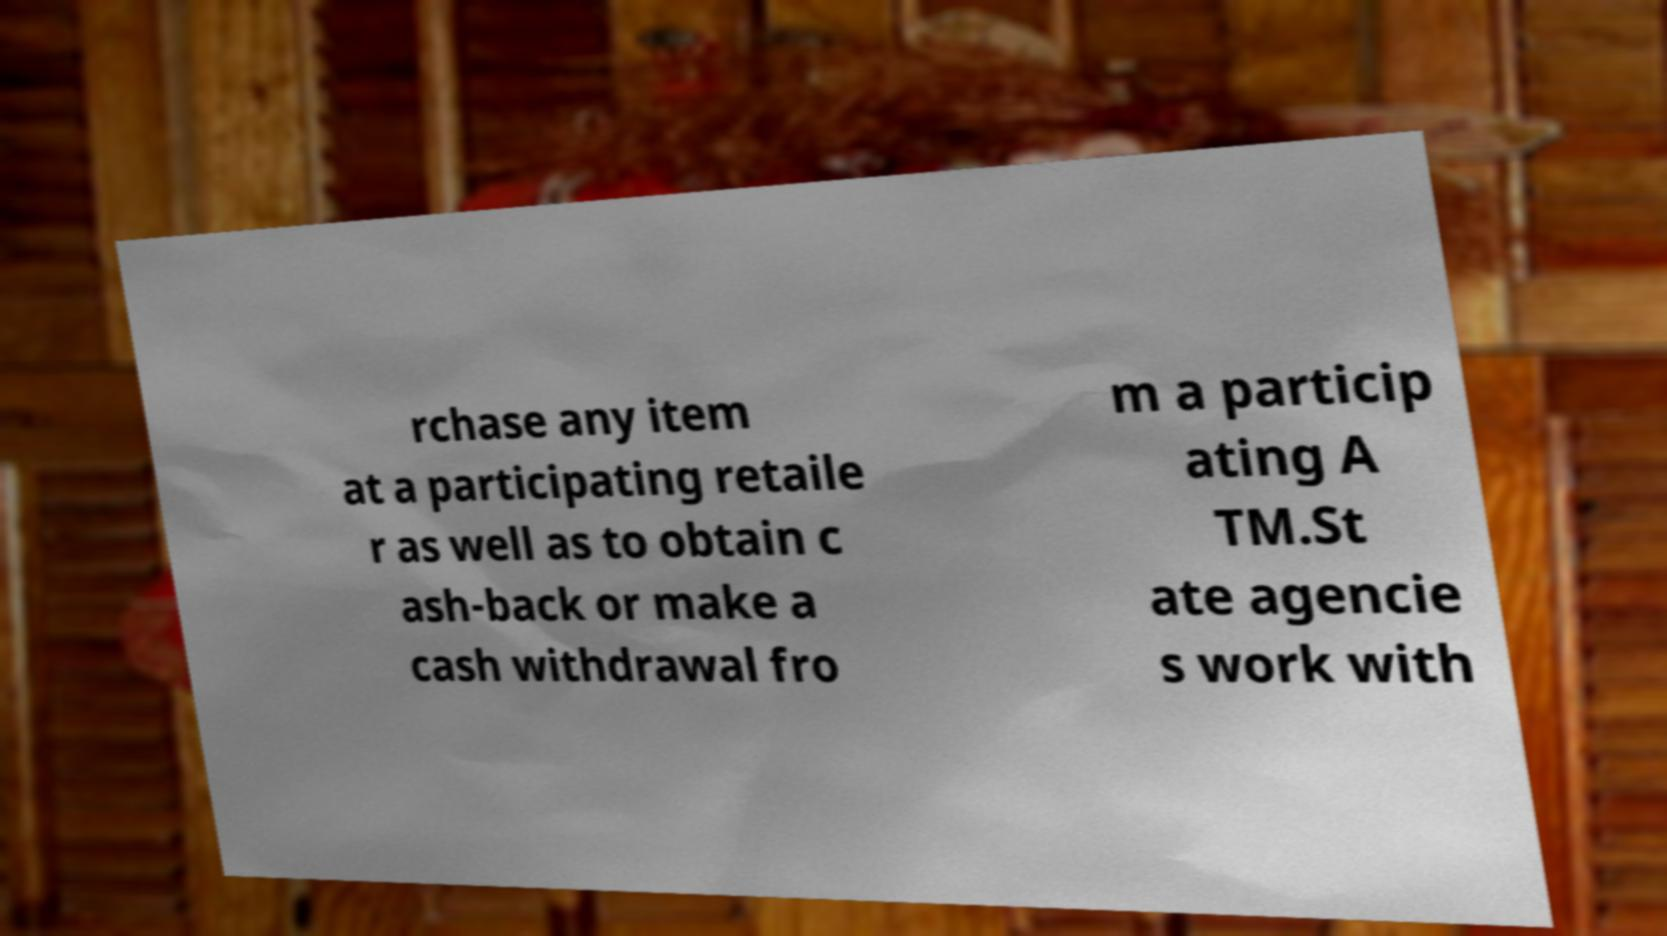There's text embedded in this image that I need extracted. Can you transcribe it verbatim? rchase any item at a participating retaile r as well as to obtain c ash-back or make a cash withdrawal fro m a particip ating A TM.St ate agencie s work with 